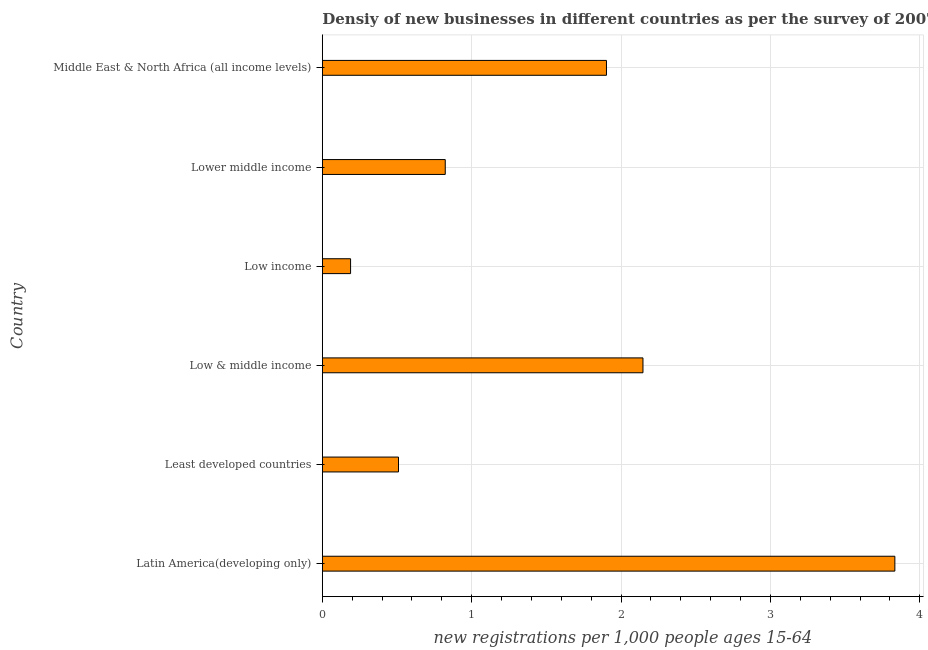Does the graph contain any zero values?
Make the answer very short. No. What is the title of the graph?
Your answer should be compact. Densiy of new businesses in different countries as per the survey of 2007. What is the label or title of the X-axis?
Give a very brief answer. New registrations per 1,0 people ages 15-64. What is the density of new business in Latin America(developing only)?
Give a very brief answer. 3.83. Across all countries, what is the maximum density of new business?
Your answer should be very brief. 3.83. Across all countries, what is the minimum density of new business?
Provide a succinct answer. 0.19. In which country was the density of new business maximum?
Your answer should be compact. Latin America(developing only). What is the sum of the density of new business?
Make the answer very short. 9.4. What is the difference between the density of new business in Latin America(developing only) and Middle East & North Africa (all income levels)?
Offer a very short reply. 1.93. What is the average density of new business per country?
Make the answer very short. 1.57. What is the median density of new business?
Keep it short and to the point. 1.36. What is the ratio of the density of new business in Latin America(developing only) to that in Middle East & North Africa (all income levels)?
Provide a short and direct response. 2.02. Is the density of new business in Latin America(developing only) less than that in Middle East & North Africa (all income levels)?
Ensure brevity in your answer.  No. Is the difference between the density of new business in Low income and Lower middle income greater than the difference between any two countries?
Your answer should be compact. No. What is the difference between the highest and the second highest density of new business?
Make the answer very short. 1.69. What is the difference between the highest and the lowest density of new business?
Your response must be concise. 3.64. In how many countries, is the density of new business greater than the average density of new business taken over all countries?
Offer a very short reply. 3. How many bars are there?
Provide a succinct answer. 6. Are the values on the major ticks of X-axis written in scientific E-notation?
Your answer should be compact. No. What is the new registrations per 1,000 people ages 15-64 in Latin America(developing only)?
Offer a very short reply. 3.83. What is the new registrations per 1,000 people ages 15-64 in Least developed countries?
Keep it short and to the point. 0.51. What is the new registrations per 1,000 people ages 15-64 in Low & middle income?
Provide a short and direct response. 2.15. What is the new registrations per 1,000 people ages 15-64 in Low income?
Offer a terse response. 0.19. What is the new registrations per 1,000 people ages 15-64 in Lower middle income?
Keep it short and to the point. 0.82. What is the new registrations per 1,000 people ages 15-64 of Middle East & North Africa (all income levels)?
Offer a very short reply. 1.9. What is the difference between the new registrations per 1,000 people ages 15-64 in Latin America(developing only) and Least developed countries?
Ensure brevity in your answer.  3.32. What is the difference between the new registrations per 1,000 people ages 15-64 in Latin America(developing only) and Low & middle income?
Keep it short and to the point. 1.69. What is the difference between the new registrations per 1,000 people ages 15-64 in Latin America(developing only) and Low income?
Keep it short and to the point. 3.64. What is the difference between the new registrations per 1,000 people ages 15-64 in Latin America(developing only) and Lower middle income?
Ensure brevity in your answer.  3.01. What is the difference between the new registrations per 1,000 people ages 15-64 in Latin America(developing only) and Middle East & North Africa (all income levels)?
Provide a succinct answer. 1.93. What is the difference between the new registrations per 1,000 people ages 15-64 in Least developed countries and Low & middle income?
Offer a terse response. -1.64. What is the difference between the new registrations per 1,000 people ages 15-64 in Least developed countries and Low income?
Offer a terse response. 0.32. What is the difference between the new registrations per 1,000 people ages 15-64 in Least developed countries and Lower middle income?
Provide a short and direct response. -0.31. What is the difference between the new registrations per 1,000 people ages 15-64 in Least developed countries and Middle East & North Africa (all income levels)?
Make the answer very short. -1.39. What is the difference between the new registrations per 1,000 people ages 15-64 in Low & middle income and Low income?
Provide a short and direct response. 1.96. What is the difference between the new registrations per 1,000 people ages 15-64 in Low & middle income and Lower middle income?
Offer a terse response. 1.32. What is the difference between the new registrations per 1,000 people ages 15-64 in Low & middle income and Middle East & North Africa (all income levels)?
Offer a very short reply. 0.24. What is the difference between the new registrations per 1,000 people ages 15-64 in Low income and Lower middle income?
Provide a succinct answer. -0.63. What is the difference between the new registrations per 1,000 people ages 15-64 in Low income and Middle East & North Africa (all income levels)?
Make the answer very short. -1.71. What is the difference between the new registrations per 1,000 people ages 15-64 in Lower middle income and Middle East & North Africa (all income levels)?
Your response must be concise. -1.08. What is the ratio of the new registrations per 1,000 people ages 15-64 in Latin America(developing only) to that in Least developed countries?
Your response must be concise. 7.52. What is the ratio of the new registrations per 1,000 people ages 15-64 in Latin America(developing only) to that in Low & middle income?
Keep it short and to the point. 1.79. What is the ratio of the new registrations per 1,000 people ages 15-64 in Latin America(developing only) to that in Low income?
Provide a short and direct response. 20.27. What is the ratio of the new registrations per 1,000 people ages 15-64 in Latin America(developing only) to that in Lower middle income?
Your response must be concise. 4.66. What is the ratio of the new registrations per 1,000 people ages 15-64 in Latin America(developing only) to that in Middle East & North Africa (all income levels)?
Provide a succinct answer. 2.02. What is the ratio of the new registrations per 1,000 people ages 15-64 in Least developed countries to that in Low & middle income?
Ensure brevity in your answer.  0.24. What is the ratio of the new registrations per 1,000 people ages 15-64 in Least developed countries to that in Low income?
Ensure brevity in your answer.  2.7. What is the ratio of the new registrations per 1,000 people ages 15-64 in Least developed countries to that in Lower middle income?
Provide a succinct answer. 0.62. What is the ratio of the new registrations per 1,000 people ages 15-64 in Least developed countries to that in Middle East & North Africa (all income levels)?
Your answer should be very brief. 0.27. What is the ratio of the new registrations per 1,000 people ages 15-64 in Low & middle income to that in Low income?
Your answer should be very brief. 11.35. What is the ratio of the new registrations per 1,000 people ages 15-64 in Low & middle income to that in Lower middle income?
Your answer should be very brief. 2.61. What is the ratio of the new registrations per 1,000 people ages 15-64 in Low & middle income to that in Middle East & North Africa (all income levels)?
Your response must be concise. 1.13. What is the ratio of the new registrations per 1,000 people ages 15-64 in Low income to that in Lower middle income?
Your answer should be very brief. 0.23. What is the ratio of the new registrations per 1,000 people ages 15-64 in Low income to that in Middle East & North Africa (all income levels)?
Keep it short and to the point. 0.1. What is the ratio of the new registrations per 1,000 people ages 15-64 in Lower middle income to that in Middle East & North Africa (all income levels)?
Offer a very short reply. 0.43. 